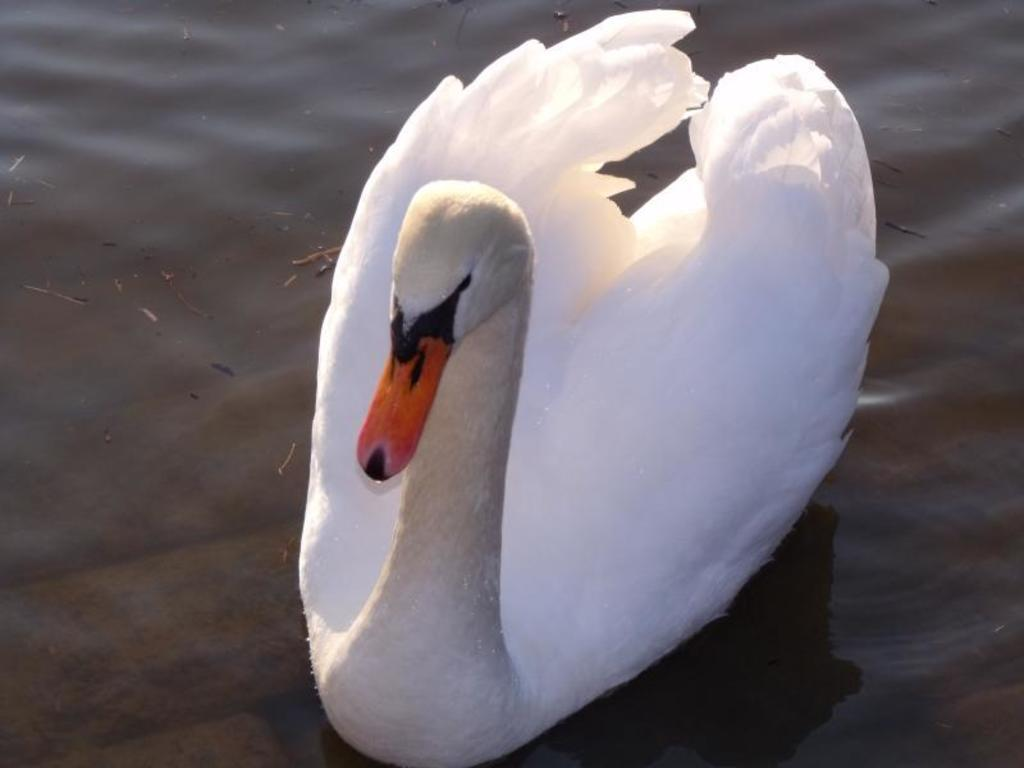What type of animal is in the image? There is a swan in the image. Where is the swan located in the image? The swan is in the water. Can you locate the map in the image? There is no map present in the image; it features a swan in the water. Is the minister wearing a boot in the image? There is no minister or boot present in the image. 